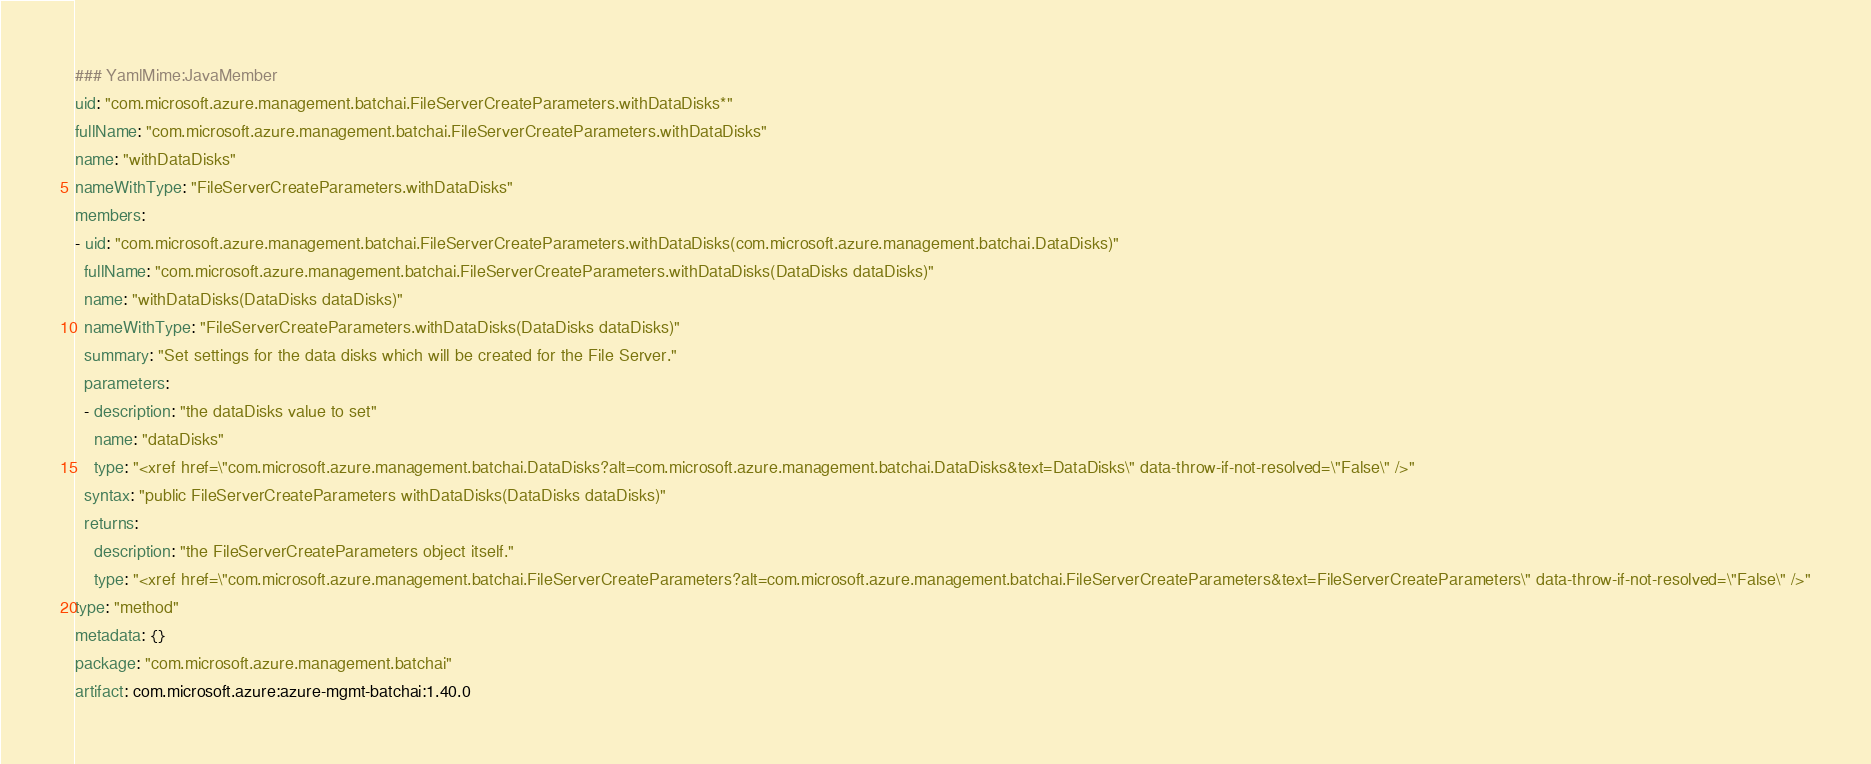<code> <loc_0><loc_0><loc_500><loc_500><_YAML_>### YamlMime:JavaMember
uid: "com.microsoft.azure.management.batchai.FileServerCreateParameters.withDataDisks*"
fullName: "com.microsoft.azure.management.batchai.FileServerCreateParameters.withDataDisks"
name: "withDataDisks"
nameWithType: "FileServerCreateParameters.withDataDisks"
members:
- uid: "com.microsoft.azure.management.batchai.FileServerCreateParameters.withDataDisks(com.microsoft.azure.management.batchai.DataDisks)"
  fullName: "com.microsoft.azure.management.batchai.FileServerCreateParameters.withDataDisks(DataDisks dataDisks)"
  name: "withDataDisks(DataDisks dataDisks)"
  nameWithType: "FileServerCreateParameters.withDataDisks(DataDisks dataDisks)"
  summary: "Set settings for the data disks which will be created for the File Server."
  parameters:
  - description: "the dataDisks value to set"
    name: "dataDisks"
    type: "<xref href=\"com.microsoft.azure.management.batchai.DataDisks?alt=com.microsoft.azure.management.batchai.DataDisks&text=DataDisks\" data-throw-if-not-resolved=\"False\" />"
  syntax: "public FileServerCreateParameters withDataDisks(DataDisks dataDisks)"
  returns:
    description: "the FileServerCreateParameters object itself."
    type: "<xref href=\"com.microsoft.azure.management.batchai.FileServerCreateParameters?alt=com.microsoft.azure.management.batchai.FileServerCreateParameters&text=FileServerCreateParameters\" data-throw-if-not-resolved=\"False\" />"
type: "method"
metadata: {}
package: "com.microsoft.azure.management.batchai"
artifact: com.microsoft.azure:azure-mgmt-batchai:1.40.0
</code> 